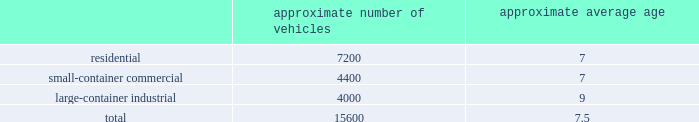We realize synergies from consolidating businesses into our existing operations , whether through acquisitions or public-private partnerships , which allow us to reduce capital and expense requirements associated with truck routing , personnel , fleet maintenance , inventories and back-office administration .
Operating model the goal of our operating model pillar is to deliver a consistent , high quality service to all of our customers through the republic way : one way .
Everywhere .
Every day .
This approach of developing standardized processes with rigorous controls and tracking allows us to leverage our scale and deliver durable operational excellence .
The republic way is the key to harnessing the best of what we do as operators and translating that across all facets of our business .
A key enabler of the republic way is our organizational structure that fosters a high performance culture by maintaining 360 degree accountability and full profit and loss responsibility with general management , supported by a functional structure to provide subject matter expertise .
This structure allows us to take advantage of our scale by coordinating functionally across all of our markets , while empowering local management to respond to unique market dynamics .
We have rolled out several productivity and cost control initiatives designed to deliver the best service possible to our customers in the most efficient and environmentally sound way .
Fleet automation approximately 72% ( 72 % ) of our residential routes have been converted to automated single driver trucks .
By converting our residential routes to automated service , we reduce labor costs , improve driver productivity , decrease emissions and create a safer work environment for our employees .
Additionally , communities using automated vehicles have higher participation rates in recycling programs , thereby complementing our initiative to expand our recycling capabilities .
Fleet conversion to compressed natural gas ( cng ) approximately 16% ( 16 % ) of our fleet operates on cng .
We expect to continue our gradual fleet conversion to cng , our preferred alternative fuel technology , as part of our ordinary annual fleet replacement process .
We believe a gradual fleet conversion is most prudent to realize the full value of our previous fleet investments .
Approximately 33% ( 33 % ) of our replacement vehicle purchases during 2015 were cng vehicles .
We believe using cng vehicles provides us a competitive advantage in communities with strict clean emission initiatives that focus on protecting the environment .
Although upfront costs are higher , using cng reduces our overall fleet operating costs through lower fuel expenses .
As of december 31 , 2015 , we operated 38 cng fueling stations .
Standardized maintenance based on an industry trade publication , we operate the ninth largest vocational fleet in the united states .
As of december 31 , 2015 , our average fleet age in years , by line of business , was as follows : approximate number of vehicles approximate average age .
Onefleet , our standardized vehicle maintenance program , enables us to use best practices for fleet management , truck care and maintenance .
Through standardization of core functions , we believe we can minimize variability .
Based on the provided information what is the approximate number of vehicles that have been converted to natural gas? 
Computations: (16% * 15600)
Answer: 2496.0. 